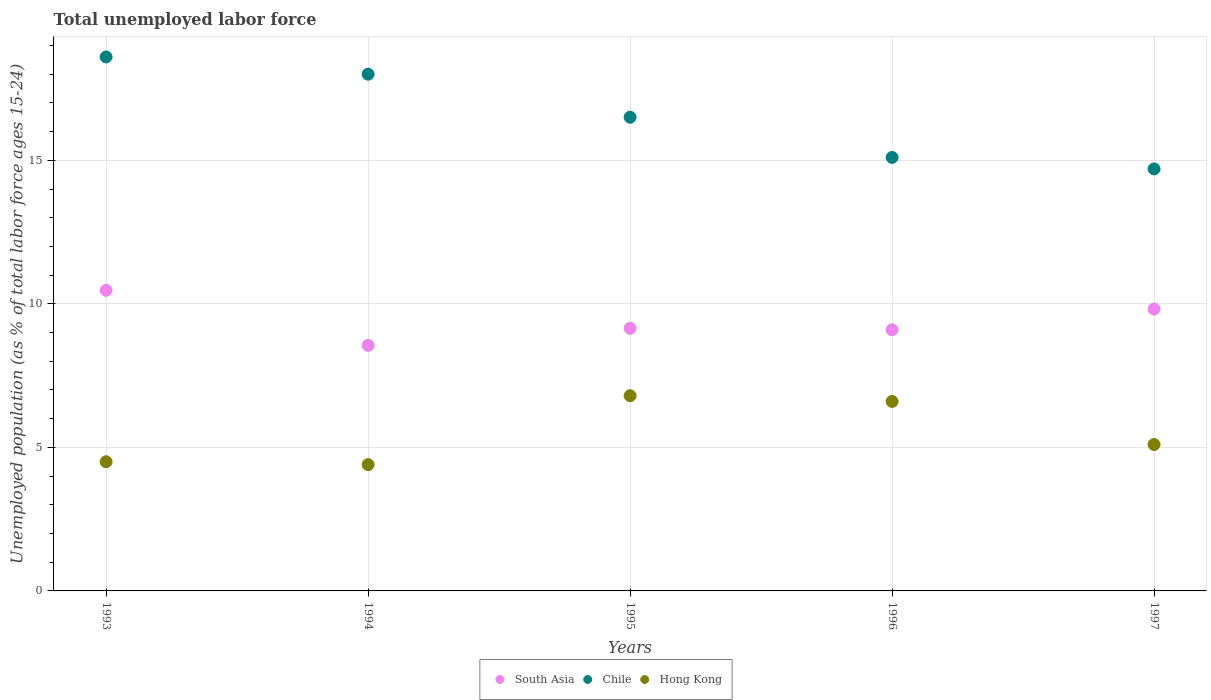Is the number of dotlines equal to the number of legend labels?
Make the answer very short. Yes. Across all years, what is the maximum percentage of unemployed population in in Chile?
Offer a very short reply. 18.6. Across all years, what is the minimum percentage of unemployed population in in Hong Kong?
Your answer should be very brief. 4.4. What is the total percentage of unemployed population in in Hong Kong in the graph?
Provide a succinct answer. 27.4. What is the difference between the percentage of unemployed population in in South Asia in 1994 and that in 1997?
Provide a succinct answer. -1.26. What is the difference between the percentage of unemployed population in in Chile in 1993 and the percentage of unemployed population in in South Asia in 1997?
Your answer should be compact. 8.78. What is the average percentage of unemployed population in in Chile per year?
Your response must be concise. 16.58. In the year 1995, what is the difference between the percentage of unemployed population in in Chile and percentage of unemployed population in in Hong Kong?
Provide a succinct answer. 9.7. In how many years, is the percentage of unemployed population in in Chile greater than 16 %?
Your answer should be compact. 3. What is the ratio of the percentage of unemployed population in in Chile in 1993 to that in 1994?
Offer a very short reply. 1.03. Is the percentage of unemployed population in in Chile in 1993 less than that in 1996?
Your answer should be very brief. No. Is the difference between the percentage of unemployed population in in Chile in 1995 and 1997 greater than the difference between the percentage of unemployed population in in Hong Kong in 1995 and 1997?
Provide a short and direct response. Yes. What is the difference between the highest and the second highest percentage of unemployed population in in Chile?
Ensure brevity in your answer.  0.6. What is the difference between the highest and the lowest percentage of unemployed population in in Chile?
Keep it short and to the point. 3.9. In how many years, is the percentage of unemployed population in in Chile greater than the average percentage of unemployed population in in Chile taken over all years?
Provide a short and direct response. 2. Is the sum of the percentage of unemployed population in in Hong Kong in 1995 and 1997 greater than the maximum percentage of unemployed population in in Chile across all years?
Provide a short and direct response. No. Is it the case that in every year, the sum of the percentage of unemployed population in in Chile and percentage of unemployed population in in South Asia  is greater than the percentage of unemployed population in in Hong Kong?
Provide a short and direct response. Yes. Does the percentage of unemployed population in in Hong Kong monotonically increase over the years?
Provide a succinct answer. No. Is the percentage of unemployed population in in Chile strictly greater than the percentage of unemployed population in in South Asia over the years?
Offer a terse response. Yes. How many dotlines are there?
Provide a short and direct response. 3. What is the difference between two consecutive major ticks on the Y-axis?
Your answer should be very brief. 5. Does the graph contain any zero values?
Your answer should be very brief. No. How many legend labels are there?
Your answer should be compact. 3. What is the title of the graph?
Make the answer very short. Total unemployed labor force. What is the label or title of the X-axis?
Provide a short and direct response. Years. What is the label or title of the Y-axis?
Give a very brief answer. Unemployed population (as % of total labor force ages 15-24). What is the Unemployed population (as % of total labor force ages 15-24) in South Asia in 1993?
Provide a succinct answer. 10.47. What is the Unemployed population (as % of total labor force ages 15-24) of Chile in 1993?
Your answer should be compact. 18.6. What is the Unemployed population (as % of total labor force ages 15-24) of Hong Kong in 1993?
Keep it short and to the point. 4.5. What is the Unemployed population (as % of total labor force ages 15-24) in South Asia in 1994?
Offer a terse response. 8.55. What is the Unemployed population (as % of total labor force ages 15-24) of Chile in 1994?
Your answer should be very brief. 18. What is the Unemployed population (as % of total labor force ages 15-24) in Hong Kong in 1994?
Your answer should be very brief. 4.4. What is the Unemployed population (as % of total labor force ages 15-24) of South Asia in 1995?
Give a very brief answer. 9.15. What is the Unemployed population (as % of total labor force ages 15-24) of Hong Kong in 1995?
Your answer should be very brief. 6.8. What is the Unemployed population (as % of total labor force ages 15-24) of South Asia in 1996?
Ensure brevity in your answer.  9.1. What is the Unemployed population (as % of total labor force ages 15-24) in Chile in 1996?
Offer a terse response. 15.1. What is the Unemployed population (as % of total labor force ages 15-24) in Hong Kong in 1996?
Your answer should be very brief. 6.6. What is the Unemployed population (as % of total labor force ages 15-24) in South Asia in 1997?
Make the answer very short. 9.82. What is the Unemployed population (as % of total labor force ages 15-24) of Chile in 1997?
Give a very brief answer. 14.7. What is the Unemployed population (as % of total labor force ages 15-24) in Hong Kong in 1997?
Ensure brevity in your answer.  5.1. Across all years, what is the maximum Unemployed population (as % of total labor force ages 15-24) of South Asia?
Provide a succinct answer. 10.47. Across all years, what is the maximum Unemployed population (as % of total labor force ages 15-24) of Chile?
Keep it short and to the point. 18.6. Across all years, what is the maximum Unemployed population (as % of total labor force ages 15-24) in Hong Kong?
Provide a short and direct response. 6.8. Across all years, what is the minimum Unemployed population (as % of total labor force ages 15-24) of South Asia?
Make the answer very short. 8.55. Across all years, what is the minimum Unemployed population (as % of total labor force ages 15-24) in Chile?
Provide a short and direct response. 14.7. Across all years, what is the minimum Unemployed population (as % of total labor force ages 15-24) in Hong Kong?
Your response must be concise. 4.4. What is the total Unemployed population (as % of total labor force ages 15-24) in South Asia in the graph?
Ensure brevity in your answer.  47.09. What is the total Unemployed population (as % of total labor force ages 15-24) of Chile in the graph?
Your answer should be very brief. 82.9. What is the total Unemployed population (as % of total labor force ages 15-24) in Hong Kong in the graph?
Offer a very short reply. 27.4. What is the difference between the Unemployed population (as % of total labor force ages 15-24) in South Asia in 1993 and that in 1994?
Make the answer very short. 1.92. What is the difference between the Unemployed population (as % of total labor force ages 15-24) of Chile in 1993 and that in 1994?
Your answer should be compact. 0.6. What is the difference between the Unemployed population (as % of total labor force ages 15-24) of South Asia in 1993 and that in 1995?
Ensure brevity in your answer.  1.32. What is the difference between the Unemployed population (as % of total labor force ages 15-24) in Chile in 1993 and that in 1995?
Your answer should be very brief. 2.1. What is the difference between the Unemployed population (as % of total labor force ages 15-24) of South Asia in 1993 and that in 1996?
Offer a terse response. 1.38. What is the difference between the Unemployed population (as % of total labor force ages 15-24) of South Asia in 1993 and that in 1997?
Provide a succinct answer. 0.65. What is the difference between the Unemployed population (as % of total labor force ages 15-24) of Hong Kong in 1993 and that in 1997?
Your answer should be compact. -0.6. What is the difference between the Unemployed population (as % of total labor force ages 15-24) of South Asia in 1994 and that in 1995?
Give a very brief answer. -0.6. What is the difference between the Unemployed population (as % of total labor force ages 15-24) of Chile in 1994 and that in 1995?
Your answer should be compact. 1.5. What is the difference between the Unemployed population (as % of total labor force ages 15-24) of Hong Kong in 1994 and that in 1995?
Keep it short and to the point. -2.4. What is the difference between the Unemployed population (as % of total labor force ages 15-24) in South Asia in 1994 and that in 1996?
Provide a short and direct response. -0.54. What is the difference between the Unemployed population (as % of total labor force ages 15-24) in Chile in 1994 and that in 1996?
Your answer should be compact. 2.9. What is the difference between the Unemployed population (as % of total labor force ages 15-24) in Hong Kong in 1994 and that in 1996?
Keep it short and to the point. -2.2. What is the difference between the Unemployed population (as % of total labor force ages 15-24) in South Asia in 1994 and that in 1997?
Ensure brevity in your answer.  -1.26. What is the difference between the Unemployed population (as % of total labor force ages 15-24) in South Asia in 1995 and that in 1996?
Offer a very short reply. 0.05. What is the difference between the Unemployed population (as % of total labor force ages 15-24) of Hong Kong in 1995 and that in 1996?
Your answer should be very brief. 0.2. What is the difference between the Unemployed population (as % of total labor force ages 15-24) in South Asia in 1995 and that in 1997?
Provide a succinct answer. -0.67. What is the difference between the Unemployed population (as % of total labor force ages 15-24) in Chile in 1995 and that in 1997?
Offer a terse response. 1.8. What is the difference between the Unemployed population (as % of total labor force ages 15-24) in South Asia in 1996 and that in 1997?
Your answer should be very brief. -0.72. What is the difference between the Unemployed population (as % of total labor force ages 15-24) of Chile in 1996 and that in 1997?
Your response must be concise. 0.4. What is the difference between the Unemployed population (as % of total labor force ages 15-24) of South Asia in 1993 and the Unemployed population (as % of total labor force ages 15-24) of Chile in 1994?
Ensure brevity in your answer.  -7.53. What is the difference between the Unemployed population (as % of total labor force ages 15-24) in South Asia in 1993 and the Unemployed population (as % of total labor force ages 15-24) in Hong Kong in 1994?
Offer a terse response. 6.07. What is the difference between the Unemployed population (as % of total labor force ages 15-24) in Chile in 1993 and the Unemployed population (as % of total labor force ages 15-24) in Hong Kong in 1994?
Your answer should be very brief. 14.2. What is the difference between the Unemployed population (as % of total labor force ages 15-24) of South Asia in 1993 and the Unemployed population (as % of total labor force ages 15-24) of Chile in 1995?
Provide a succinct answer. -6.03. What is the difference between the Unemployed population (as % of total labor force ages 15-24) of South Asia in 1993 and the Unemployed population (as % of total labor force ages 15-24) of Hong Kong in 1995?
Your answer should be very brief. 3.67. What is the difference between the Unemployed population (as % of total labor force ages 15-24) of South Asia in 1993 and the Unemployed population (as % of total labor force ages 15-24) of Chile in 1996?
Make the answer very short. -4.63. What is the difference between the Unemployed population (as % of total labor force ages 15-24) of South Asia in 1993 and the Unemployed population (as % of total labor force ages 15-24) of Hong Kong in 1996?
Keep it short and to the point. 3.87. What is the difference between the Unemployed population (as % of total labor force ages 15-24) of South Asia in 1993 and the Unemployed population (as % of total labor force ages 15-24) of Chile in 1997?
Make the answer very short. -4.23. What is the difference between the Unemployed population (as % of total labor force ages 15-24) of South Asia in 1993 and the Unemployed population (as % of total labor force ages 15-24) of Hong Kong in 1997?
Ensure brevity in your answer.  5.37. What is the difference between the Unemployed population (as % of total labor force ages 15-24) in South Asia in 1994 and the Unemployed population (as % of total labor force ages 15-24) in Chile in 1995?
Keep it short and to the point. -7.95. What is the difference between the Unemployed population (as % of total labor force ages 15-24) in South Asia in 1994 and the Unemployed population (as % of total labor force ages 15-24) in Hong Kong in 1995?
Keep it short and to the point. 1.75. What is the difference between the Unemployed population (as % of total labor force ages 15-24) of South Asia in 1994 and the Unemployed population (as % of total labor force ages 15-24) of Chile in 1996?
Offer a very short reply. -6.55. What is the difference between the Unemployed population (as % of total labor force ages 15-24) of South Asia in 1994 and the Unemployed population (as % of total labor force ages 15-24) of Hong Kong in 1996?
Give a very brief answer. 1.95. What is the difference between the Unemployed population (as % of total labor force ages 15-24) in South Asia in 1994 and the Unemployed population (as % of total labor force ages 15-24) in Chile in 1997?
Provide a short and direct response. -6.15. What is the difference between the Unemployed population (as % of total labor force ages 15-24) of South Asia in 1994 and the Unemployed population (as % of total labor force ages 15-24) of Hong Kong in 1997?
Keep it short and to the point. 3.45. What is the difference between the Unemployed population (as % of total labor force ages 15-24) in South Asia in 1995 and the Unemployed population (as % of total labor force ages 15-24) in Chile in 1996?
Your response must be concise. -5.95. What is the difference between the Unemployed population (as % of total labor force ages 15-24) in South Asia in 1995 and the Unemployed population (as % of total labor force ages 15-24) in Hong Kong in 1996?
Provide a short and direct response. 2.55. What is the difference between the Unemployed population (as % of total labor force ages 15-24) in Chile in 1995 and the Unemployed population (as % of total labor force ages 15-24) in Hong Kong in 1996?
Provide a short and direct response. 9.9. What is the difference between the Unemployed population (as % of total labor force ages 15-24) of South Asia in 1995 and the Unemployed population (as % of total labor force ages 15-24) of Chile in 1997?
Your answer should be very brief. -5.55. What is the difference between the Unemployed population (as % of total labor force ages 15-24) in South Asia in 1995 and the Unemployed population (as % of total labor force ages 15-24) in Hong Kong in 1997?
Keep it short and to the point. 4.05. What is the difference between the Unemployed population (as % of total labor force ages 15-24) in Chile in 1995 and the Unemployed population (as % of total labor force ages 15-24) in Hong Kong in 1997?
Your answer should be compact. 11.4. What is the difference between the Unemployed population (as % of total labor force ages 15-24) of South Asia in 1996 and the Unemployed population (as % of total labor force ages 15-24) of Chile in 1997?
Provide a succinct answer. -5.6. What is the difference between the Unemployed population (as % of total labor force ages 15-24) of South Asia in 1996 and the Unemployed population (as % of total labor force ages 15-24) of Hong Kong in 1997?
Give a very brief answer. 4. What is the difference between the Unemployed population (as % of total labor force ages 15-24) of Chile in 1996 and the Unemployed population (as % of total labor force ages 15-24) of Hong Kong in 1997?
Provide a succinct answer. 10. What is the average Unemployed population (as % of total labor force ages 15-24) in South Asia per year?
Keep it short and to the point. 9.42. What is the average Unemployed population (as % of total labor force ages 15-24) in Chile per year?
Your answer should be compact. 16.58. What is the average Unemployed population (as % of total labor force ages 15-24) in Hong Kong per year?
Your response must be concise. 5.48. In the year 1993, what is the difference between the Unemployed population (as % of total labor force ages 15-24) in South Asia and Unemployed population (as % of total labor force ages 15-24) in Chile?
Make the answer very short. -8.13. In the year 1993, what is the difference between the Unemployed population (as % of total labor force ages 15-24) in South Asia and Unemployed population (as % of total labor force ages 15-24) in Hong Kong?
Your answer should be compact. 5.97. In the year 1994, what is the difference between the Unemployed population (as % of total labor force ages 15-24) of South Asia and Unemployed population (as % of total labor force ages 15-24) of Chile?
Keep it short and to the point. -9.45. In the year 1994, what is the difference between the Unemployed population (as % of total labor force ages 15-24) of South Asia and Unemployed population (as % of total labor force ages 15-24) of Hong Kong?
Your answer should be very brief. 4.15. In the year 1994, what is the difference between the Unemployed population (as % of total labor force ages 15-24) of Chile and Unemployed population (as % of total labor force ages 15-24) of Hong Kong?
Provide a succinct answer. 13.6. In the year 1995, what is the difference between the Unemployed population (as % of total labor force ages 15-24) of South Asia and Unemployed population (as % of total labor force ages 15-24) of Chile?
Ensure brevity in your answer.  -7.35. In the year 1995, what is the difference between the Unemployed population (as % of total labor force ages 15-24) in South Asia and Unemployed population (as % of total labor force ages 15-24) in Hong Kong?
Ensure brevity in your answer.  2.35. In the year 1995, what is the difference between the Unemployed population (as % of total labor force ages 15-24) of Chile and Unemployed population (as % of total labor force ages 15-24) of Hong Kong?
Your response must be concise. 9.7. In the year 1996, what is the difference between the Unemployed population (as % of total labor force ages 15-24) of South Asia and Unemployed population (as % of total labor force ages 15-24) of Chile?
Provide a short and direct response. -6. In the year 1996, what is the difference between the Unemployed population (as % of total labor force ages 15-24) in South Asia and Unemployed population (as % of total labor force ages 15-24) in Hong Kong?
Your response must be concise. 2.5. In the year 1996, what is the difference between the Unemployed population (as % of total labor force ages 15-24) in Chile and Unemployed population (as % of total labor force ages 15-24) in Hong Kong?
Your answer should be compact. 8.5. In the year 1997, what is the difference between the Unemployed population (as % of total labor force ages 15-24) in South Asia and Unemployed population (as % of total labor force ages 15-24) in Chile?
Provide a short and direct response. -4.88. In the year 1997, what is the difference between the Unemployed population (as % of total labor force ages 15-24) in South Asia and Unemployed population (as % of total labor force ages 15-24) in Hong Kong?
Your response must be concise. 4.72. In the year 1997, what is the difference between the Unemployed population (as % of total labor force ages 15-24) in Chile and Unemployed population (as % of total labor force ages 15-24) in Hong Kong?
Provide a short and direct response. 9.6. What is the ratio of the Unemployed population (as % of total labor force ages 15-24) of South Asia in 1993 to that in 1994?
Provide a short and direct response. 1.22. What is the ratio of the Unemployed population (as % of total labor force ages 15-24) in Hong Kong in 1993 to that in 1994?
Your answer should be compact. 1.02. What is the ratio of the Unemployed population (as % of total labor force ages 15-24) of South Asia in 1993 to that in 1995?
Your answer should be very brief. 1.14. What is the ratio of the Unemployed population (as % of total labor force ages 15-24) in Chile in 1993 to that in 1995?
Your answer should be compact. 1.13. What is the ratio of the Unemployed population (as % of total labor force ages 15-24) of Hong Kong in 1993 to that in 1995?
Provide a succinct answer. 0.66. What is the ratio of the Unemployed population (as % of total labor force ages 15-24) of South Asia in 1993 to that in 1996?
Provide a short and direct response. 1.15. What is the ratio of the Unemployed population (as % of total labor force ages 15-24) in Chile in 1993 to that in 1996?
Provide a succinct answer. 1.23. What is the ratio of the Unemployed population (as % of total labor force ages 15-24) of Hong Kong in 1993 to that in 1996?
Keep it short and to the point. 0.68. What is the ratio of the Unemployed population (as % of total labor force ages 15-24) in South Asia in 1993 to that in 1997?
Offer a very short reply. 1.07. What is the ratio of the Unemployed population (as % of total labor force ages 15-24) of Chile in 1993 to that in 1997?
Make the answer very short. 1.27. What is the ratio of the Unemployed population (as % of total labor force ages 15-24) of Hong Kong in 1993 to that in 1997?
Your answer should be very brief. 0.88. What is the ratio of the Unemployed population (as % of total labor force ages 15-24) in South Asia in 1994 to that in 1995?
Give a very brief answer. 0.93. What is the ratio of the Unemployed population (as % of total labor force ages 15-24) of Chile in 1994 to that in 1995?
Provide a short and direct response. 1.09. What is the ratio of the Unemployed population (as % of total labor force ages 15-24) of Hong Kong in 1994 to that in 1995?
Give a very brief answer. 0.65. What is the ratio of the Unemployed population (as % of total labor force ages 15-24) of South Asia in 1994 to that in 1996?
Provide a succinct answer. 0.94. What is the ratio of the Unemployed population (as % of total labor force ages 15-24) in Chile in 1994 to that in 1996?
Your answer should be compact. 1.19. What is the ratio of the Unemployed population (as % of total labor force ages 15-24) in South Asia in 1994 to that in 1997?
Your response must be concise. 0.87. What is the ratio of the Unemployed population (as % of total labor force ages 15-24) of Chile in 1994 to that in 1997?
Your answer should be compact. 1.22. What is the ratio of the Unemployed population (as % of total labor force ages 15-24) in Hong Kong in 1994 to that in 1997?
Provide a short and direct response. 0.86. What is the ratio of the Unemployed population (as % of total labor force ages 15-24) in South Asia in 1995 to that in 1996?
Your response must be concise. 1.01. What is the ratio of the Unemployed population (as % of total labor force ages 15-24) of Chile in 1995 to that in 1996?
Your answer should be very brief. 1.09. What is the ratio of the Unemployed population (as % of total labor force ages 15-24) of Hong Kong in 1995 to that in 1996?
Your response must be concise. 1.03. What is the ratio of the Unemployed population (as % of total labor force ages 15-24) of South Asia in 1995 to that in 1997?
Give a very brief answer. 0.93. What is the ratio of the Unemployed population (as % of total labor force ages 15-24) of Chile in 1995 to that in 1997?
Your answer should be compact. 1.12. What is the ratio of the Unemployed population (as % of total labor force ages 15-24) of South Asia in 1996 to that in 1997?
Provide a succinct answer. 0.93. What is the ratio of the Unemployed population (as % of total labor force ages 15-24) in Chile in 1996 to that in 1997?
Your answer should be compact. 1.03. What is the ratio of the Unemployed population (as % of total labor force ages 15-24) in Hong Kong in 1996 to that in 1997?
Provide a short and direct response. 1.29. What is the difference between the highest and the second highest Unemployed population (as % of total labor force ages 15-24) of South Asia?
Your answer should be very brief. 0.65. What is the difference between the highest and the second highest Unemployed population (as % of total labor force ages 15-24) of Chile?
Keep it short and to the point. 0.6. What is the difference between the highest and the second highest Unemployed population (as % of total labor force ages 15-24) in Hong Kong?
Offer a terse response. 0.2. What is the difference between the highest and the lowest Unemployed population (as % of total labor force ages 15-24) of South Asia?
Offer a very short reply. 1.92. What is the difference between the highest and the lowest Unemployed population (as % of total labor force ages 15-24) in Chile?
Provide a succinct answer. 3.9. What is the difference between the highest and the lowest Unemployed population (as % of total labor force ages 15-24) of Hong Kong?
Ensure brevity in your answer.  2.4. 